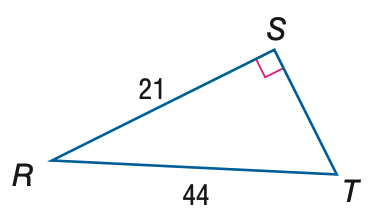Answer the mathemtical geometry problem and directly provide the correct option letter.
Question: Find the measure of \angle T to the nearest tenth.
Choices: A: 25.5 B: 28.5 C: 61.5 D: 64.5 B 